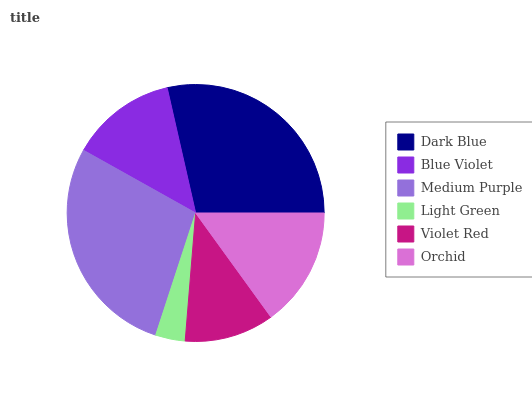Is Light Green the minimum?
Answer yes or no. Yes. Is Dark Blue the maximum?
Answer yes or no. Yes. Is Blue Violet the minimum?
Answer yes or no. No. Is Blue Violet the maximum?
Answer yes or no. No. Is Dark Blue greater than Blue Violet?
Answer yes or no. Yes. Is Blue Violet less than Dark Blue?
Answer yes or no. Yes. Is Blue Violet greater than Dark Blue?
Answer yes or no. No. Is Dark Blue less than Blue Violet?
Answer yes or no. No. Is Orchid the high median?
Answer yes or no. Yes. Is Blue Violet the low median?
Answer yes or no. Yes. Is Violet Red the high median?
Answer yes or no. No. Is Orchid the low median?
Answer yes or no. No. 